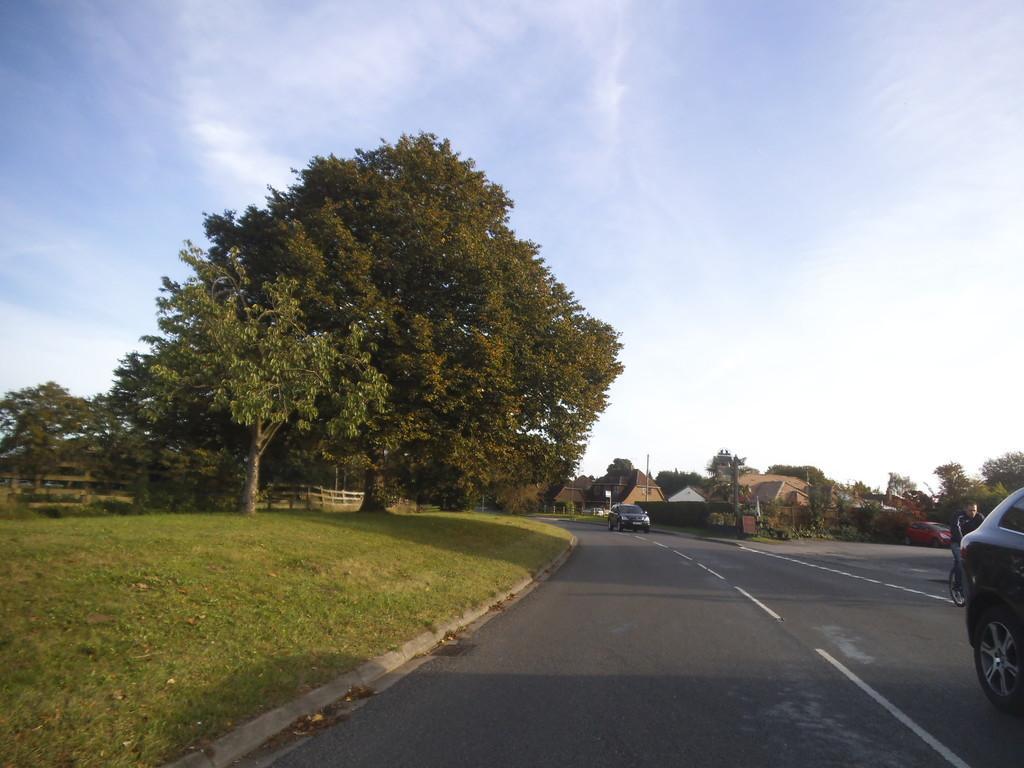Please provide a concise description of this image. In this image I can see the road, few vehicles on the road, a person riding the bicycle on the road, some grass, the fencing, few trees which are green in color and few buildings. In the background I can see the sky. 